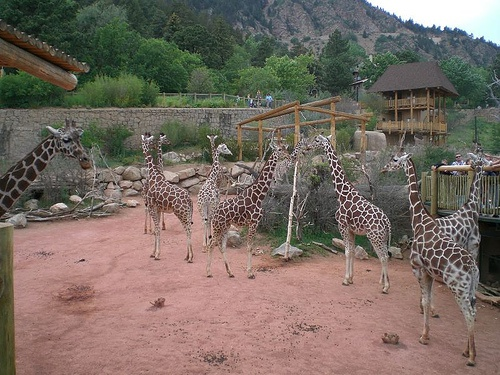Describe the objects in this image and their specific colors. I can see giraffe in darkgreen, gray, darkgray, and black tones, giraffe in darkgreen, gray, darkgray, and black tones, giraffe in darkgreen, gray, black, and darkgray tones, giraffe in darkgreen, darkgray, gray, and maroon tones, and giraffe in darkgreen, gray, darkgray, and maroon tones in this image. 